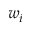Convert formula to latex. <formula><loc_0><loc_0><loc_500><loc_500>w _ { i }</formula> 